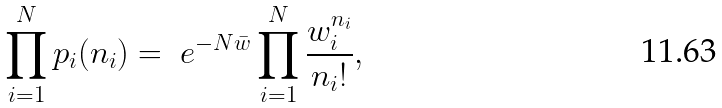Convert formula to latex. <formula><loc_0><loc_0><loc_500><loc_500>\prod _ { i = 1 } ^ { N } p _ { i } ( n _ { i } ) = \ e ^ { - N \bar { w } } \prod _ { i = 1 } ^ { N } \frac { w _ { i } ^ { n _ { i } } } { n _ { i } ! } ,</formula> 